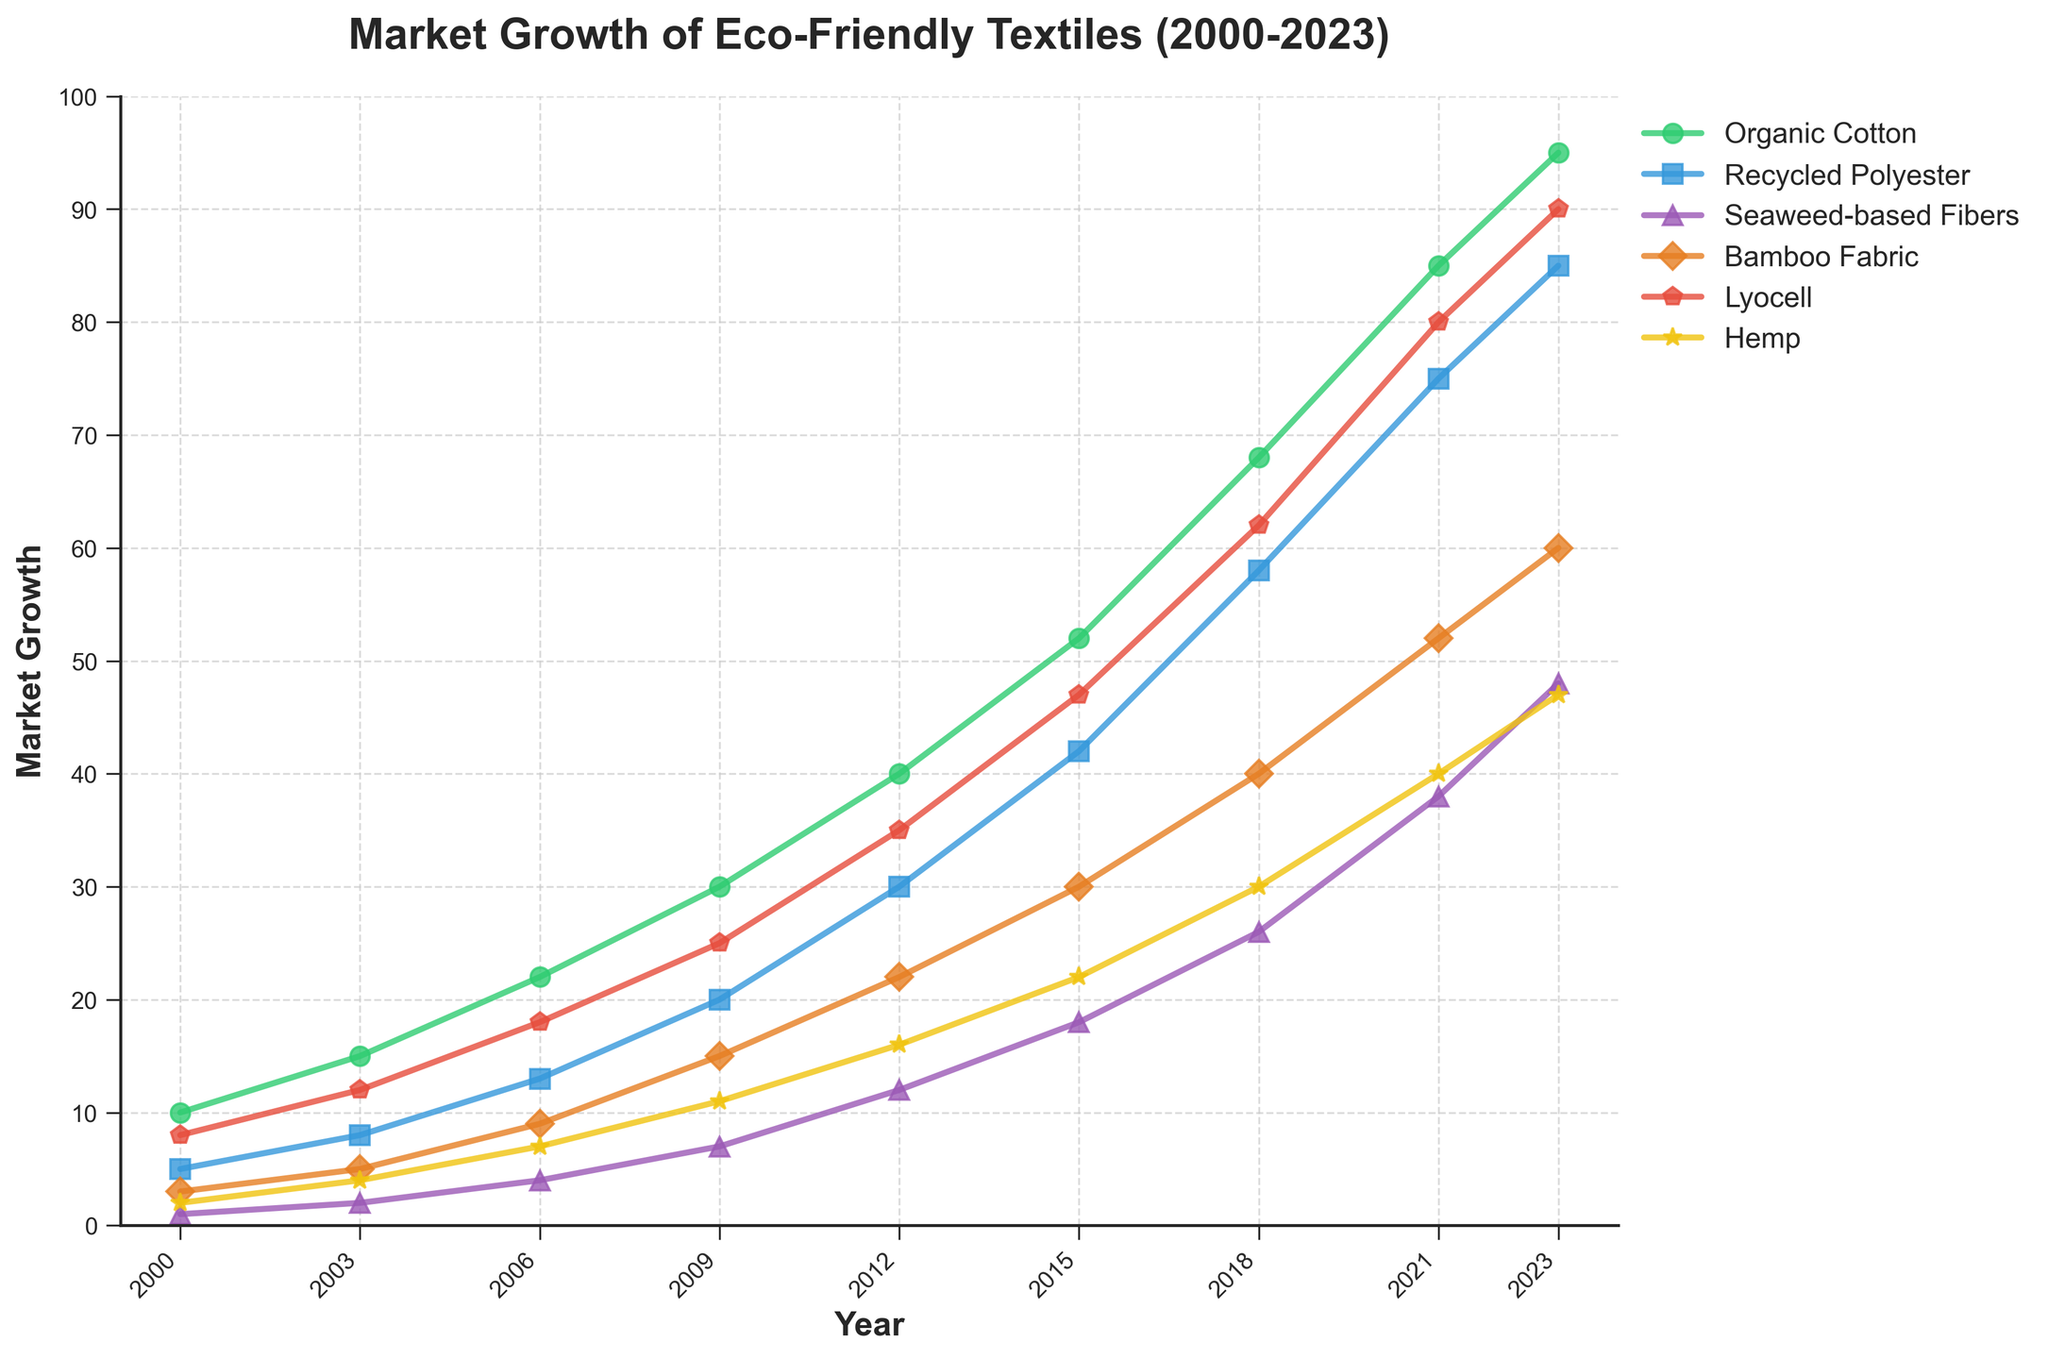What's the trend in market growth for Seaweed-based Fibers from 2000 to 2023? Observing the line for Seaweed-based Fibers on the chart, it starts at 1 in 2000 and steadily increases, reaching 48 in 2023. The trend shows growth over the years with a clear upward trajectory.
Answer: Steady upward trend Which material had the highest market growth in 2023? Looking at the endpoints of all lines in 2023, Organic Cotton reaches the highest value at 95.
Answer: Organic Cotton Between 2006 and 2009, which material showed the largest increase in market growth? Calculating the difference for each material between these years:
- Organic Cotton: 30 - 22 = 8
- Recycled Polyester: 20 - 13 = 7
- Seaweed-based Fibers: 7 - 4 = 3
- Bamboo Fabric: 15 - 9 = 6
- Lyocell: 25 - 18 = 7
- Hemp: 11 - 7 = 4
Organic Cotton has the largest increase of 8.
Answer: Organic Cotton What is the difference in market growth between Recycled Polyester and Bamboo Fabric in 2021? In 2021, Recycled Polyester is at 75, and Bamboo Fabric is at 52. The difference is 75 - 52 = 23.
Answer: 23 How does the growth of Hemp compare to Lyocell in 2018? In 2018, Hemp reaches 30, and Lyocell is at 62. Comparing these, Lyocell has more than double the market growth of Hemp.
Answer: Lyocell is more than double Which material has shown consistent linear growth over the years? By analyzing the slope of the lines, Recycled Polyester consistently shows steady, linear growth through the years without sharp spikes or dips.
Answer: Recycled Polyester What was the combined market growth of Organic Cotton and Bamboo Fabric in 2015? In 2015, Organic Cotton is at 52, and Bamboo Fabric is at 30. Their combined growth is 52 + 30 = 82.
Answer: 82 Between 2003 and 2006, which material had a minimal increase in market share? Calculating the differences:
- Organic Cotton: 22 - 15 = 7
- Recycled Polyester: 13 - 8 = 5
- Seaweed-based Fibers: 4 - 2 = 2
- Bamboo Fabric: 9 - 5 = 4
- Lyocell: 18 - 12 = 6
- Hemp: 7 - 4 = 3
Seaweed-based Fibers had the smallest increase of 2.
Answer: Seaweed-based Fibers In which year did Lyocell surpass 30 in market growth? Observing the Lyocell line, it first surpasses 30 in the year 2012.
Answer: 2012 What is the average annual growth rate of Seaweed-based Fibers from 2000 to 2023? The initial value in 2000 is 1, and the final value in 2023 is 48. The period is 23 years:
48 - 1 = 47 total growth over 23 years.
Average annual growth rate: 47 / 23 ≈ 2.04.
Answer: ≈ 2.04 